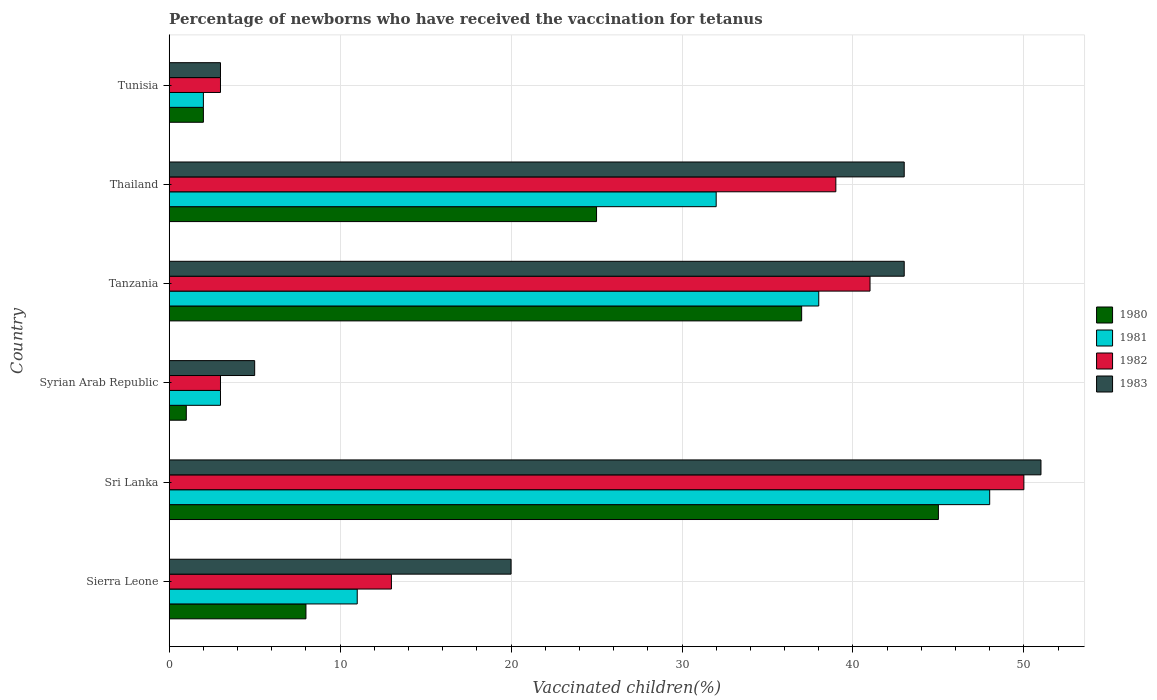How many groups of bars are there?
Provide a succinct answer. 6. Are the number of bars per tick equal to the number of legend labels?
Offer a terse response. Yes. How many bars are there on the 2nd tick from the bottom?
Your response must be concise. 4. What is the label of the 1st group of bars from the top?
Offer a terse response. Tunisia. What is the percentage of vaccinated children in 1983 in Tunisia?
Keep it short and to the point. 3. Across all countries, what is the minimum percentage of vaccinated children in 1981?
Ensure brevity in your answer.  2. In which country was the percentage of vaccinated children in 1980 maximum?
Make the answer very short. Sri Lanka. In which country was the percentage of vaccinated children in 1982 minimum?
Your answer should be very brief. Syrian Arab Republic. What is the total percentage of vaccinated children in 1983 in the graph?
Offer a terse response. 165. What is the difference between the percentage of vaccinated children in 1980 in Thailand and that in Tunisia?
Ensure brevity in your answer.  23. What is the difference between the percentage of vaccinated children in 1983 in Tunisia and the percentage of vaccinated children in 1980 in Tanzania?
Ensure brevity in your answer.  -34. What is the average percentage of vaccinated children in 1980 per country?
Provide a short and direct response. 19.67. What is the difference between the percentage of vaccinated children in 1981 and percentage of vaccinated children in 1983 in Sri Lanka?
Give a very brief answer. -3. In how many countries, is the percentage of vaccinated children in 1980 greater than 2 %?
Your answer should be very brief. 4. What is the ratio of the percentage of vaccinated children in 1983 in Tanzania to that in Thailand?
Give a very brief answer. 1. Is the percentage of vaccinated children in 1983 in Sierra Leone less than that in Syrian Arab Republic?
Your answer should be compact. No. Is the difference between the percentage of vaccinated children in 1981 in Sri Lanka and Thailand greater than the difference between the percentage of vaccinated children in 1983 in Sri Lanka and Thailand?
Keep it short and to the point. Yes. What is the difference between the highest and the second highest percentage of vaccinated children in 1982?
Your answer should be compact. 9. What is the difference between the highest and the lowest percentage of vaccinated children in 1980?
Offer a terse response. 44. In how many countries, is the percentage of vaccinated children in 1980 greater than the average percentage of vaccinated children in 1980 taken over all countries?
Your answer should be compact. 3. Is the sum of the percentage of vaccinated children in 1982 in Tanzania and Thailand greater than the maximum percentage of vaccinated children in 1980 across all countries?
Make the answer very short. Yes. What does the 2nd bar from the top in Syrian Arab Republic represents?
Offer a terse response. 1982. What does the 2nd bar from the bottom in Tunisia represents?
Offer a very short reply. 1981. Is it the case that in every country, the sum of the percentage of vaccinated children in 1983 and percentage of vaccinated children in 1981 is greater than the percentage of vaccinated children in 1982?
Give a very brief answer. Yes. Are all the bars in the graph horizontal?
Provide a succinct answer. Yes. Are the values on the major ticks of X-axis written in scientific E-notation?
Offer a terse response. No. Where does the legend appear in the graph?
Keep it short and to the point. Center right. How many legend labels are there?
Ensure brevity in your answer.  4. What is the title of the graph?
Make the answer very short. Percentage of newborns who have received the vaccination for tetanus. What is the label or title of the X-axis?
Offer a terse response. Vaccinated children(%). What is the Vaccinated children(%) of 1980 in Sierra Leone?
Ensure brevity in your answer.  8. What is the Vaccinated children(%) of 1982 in Sierra Leone?
Your response must be concise. 13. What is the Vaccinated children(%) in 1983 in Sierra Leone?
Provide a short and direct response. 20. What is the Vaccinated children(%) in 1980 in Sri Lanka?
Give a very brief answer. 45. What is the Vaccinated children(%) in 1981 in Sri Lanka?
Give a very brief answer. 48. What is the Vaccinated children(%) of 1980 in Syrian Arab Republic?
Give a very brief answer. 1. What is the Vaccinated children(%) in 1983 in Syrian Arab Republic?
Provide a short and direct response. 5. What is the Vaccinated children(%) in 1982 in Tanzania?
Provide a short and direct response. 41. What is the Vaccinated children(%) of 1980 in Thailand?
Provide a succinct answer. 25. What is the Vaccinated children(%) in 1982 in Thailand?
Your response must be concise. 39. What is the Vaccinated children(%) of 1980 in Tunisia?
Keep it short and to the point. 2. Across all countries, what is the maximum Vaccinated children(%) of 1980?
Your response must be concise. 45. Across all countries, what is the maximum Vaccinated children(%) in 1982?
Make the answer very short. 50. Across all countries, what is the maximum Vaccinated children(%) of 1983?
Give a very brief answer. 51. Across all countries, what is the minimum Vaccinated children(%) in 1981?
Your response must be concise. 2. Across all countries, what is the minimum Vaccinated children(%) in 1982?
Keep it short and to the point. 3. Across all countries, what is the minimum Vaccinated children(%) in 1983?
Offer a very short reply. 3. What is the total Vaccinated children(%) of 1980 in the graph?
Provide a succinct answer. 118. What is the total Vaccinated children(%) of 1981 in the graph?
Keep it short and to the point. 134. What is the total Vaccinated children(%) of 1982 in the graph?
Your answer should be compact. 149. What is the total Vaccinated children(%) in 1983 in the graph?
Your answer should be very brief. 165. What is the difference between the Vaccinated children(%) in 1980 in Sierra Leone and that in Sri Lanka?
Give a very brief answer. -37. What is the difference between the Vaccinated children(%) of 1981 in Sierra Leone and that in Sri Lanka?
Give a very brief answer. -37. What is the difference between the Vaccinated children(%) of 1982 in Sierra Leone and that in Sri Lanka?
Ensure brevity in your answer.  -37. What is the difference between the Vaccinated children(%) of 1983 in Sierra Leone and that in Sri Lanka?
Your answer should be compact. -31. What is the difference between the Vaccinated children(%) of 1982 in Sierra Leone and that in Syrian Arab Republic?
Your answer should be compact. 10. What is the difference between the Vaccinated children(%) in 1983 in Sierra Leone and that in Syrian Arab Republic?
Your answer should be compact. 15. What is the difference between the Vaccinated children(%) in 1980 in Sierra Leone and that in Tanzania?
Keep it short and to the point. -29. What is the difference between the Vaccinated children(%) in 1981 in Sierra Leone and that in Tanzania?
Your answer should be compact. -27. What is the difference between the Vaccinated children(%) in 1982 in Sierra Leone and that in Tanzania?
Ensure brevity in your answer.  -28. What is the difference between the Vaccinated children(%) in 1983 in Sierra Leone and that in Tanzania?
Provide a short and direct response. -23. What is the difference between the Vaccinated children(%) of 1980 in Sierra Leone and that in Thailand?
Give a very brief answer. -17. What is the difference between the Vaccinated children(%) in 1981 in Sierra Leone and that in Tunisia?
Your answer should be compact. 9. What is the difference between the Vaccinated children(%) of 1980 in Sri Lanka and that in Syrian Arab Republic?
Your answer should be compact. 44. What is the difference between the Vaccinated children(%) in 1981 in Sri Lanka and that in Syrian Arab Republic?
Give a very brief answer. 45. What is the difference between the Vaccinated children(%) of 1983 in Sri Lanka and that in Syrian Arab Republic?
Provide a short and direct response. 46. What is the difference between the Vaccinated children(%) in 1981 in Sri Lanka and that in Tanzania?
Your answer should be very brief. 10. What is the difference between the Vaccinated children(%) of 1982 in Sri Lanka and that in Tanzania?
Your answer should be compact. 9. What is the difference between the Vaccinated children(%) in 1980 in Sri Lanka and that in Thailand?
Ensure brevity in your answer.  20. What is the difference between the Vaccinated children(%) of 1983 in Sri Lanka and that in Thailand?
Your answer should be very brief. 8. What is the difference between the Vaccinated children(%) in 1982 in Sri Lanka and that in Tunisia?
Provide a short and direct response. 47. What is the difference between the Vaccinated children(%) of 1983 in Sri Lanka and that in Tunisia?
Provide a succinct answer. 48. What is the difference between the Vaccinated children(%) in 1980 in Syrian Arab Republic and that in Tanzania?
Ensure brevity in your answer.  -36. What is the difference between the Vaccinated children(%) of 1981 in Syrian Arab Republic and that in Tanzania?
Your answer should be compact. -35. What is the difference between the Vaccinated children(%) of 1982 in Syrian Arab Republic and that in Tanzania?
Provide a short and direct response. -38. What is the difference between the Vaccinated children(%) in 1983 in Syrian Arab Republic and that in Tanzania?
Offer a very short reply. -38. What is the difference between the Vaccinated children(%) in 1982 in Syrian Arab Republic and that in Thailand?
Make the answer very short. -36. What is the difference between the Vaccinated children(%) in 1983 in Syrian Arab Republic and that in Thailand?
Your answer should be compact. -38. What is the difference between the Vaccinated children(%) of 1981 in Syrian Arab Republic and that in Tunisia?
Your answer should be very brief. 1. What is the difference between the Vaccinated children(%) of 1982 in Syrian Arab Republic and that in Tunisia?
Your response must be concise. 0. What is the difference between the Vaccinated children(%) in 1982 in Tanzania and that in Thailand?
Make the answer very short. 2. What is the difference between the Vaccinated children(%) in 1983 in Tanzania and that in Thailand?
Provide a succinct answer. 0. What is the difference between the Vaccinated children(%) of 1981 in Tanzania and that in Tunisia?
Your answer should be compact. 36. What is the difference between the Vaccinated children(%) of 1983 in Tanzania and that in Tunisia?
Give a very brief answer. 40. What is the difference between the Vaccinated children(%) of 1980 in Thailand and that in Tunisia?
Give a very brief answer. 23. What is the difference between the Vaccinated children(%) of 1982 in Thailand and that in Tunisia?
Make the answer very short. 36. What is the difference between the Vaccinated children(%) of 1983 in Thailand and that in Tunisia?
Offer a very short reply. 40. What is the difference between the Vaccinated children(%) of 1980 in Sierra Leone and the Vaccinated children(%) of 1981 in Sri Lanka?
Provide a short and direct response. -40. What is the difference between the Vaccinated children(%) of 1980 in Sierra Leone and the Vaccinated children(%) of 1982 in Sri Lanka?
Give a very brief answer. -42. What is the difference between the Vaccinated children(%) of 1980 in Sierra Leone and the Vaccinated children(%) of 1983 in Sri Lanka?
Offer a terse response. -43. What is the difference between the Vaccinated children(%) in 1981 in Sierra Leone and the Vaccinated children(%) in 1982 in Sri Lanka?
Provide a short and direct response. -39. What is the difference between the Vaccinated children(%) of 1982 in Sierra Leone and the Vaccinated children(%) of 1983 in Sri Lanka?
Keep it short and to the point. -38. What is the difference between the Vaccinated children(%) of 1980 in Sierra Leone and the Vaccinated children(%) of 1981 in Syrian Arab Republic?
Offer a very short reply. 5. What is the difference between the Vaccinated children(%) of 1980 in Sierra Leone and the Vaccinated children(%) of 1982 in Syrian Arab Republic?
Your answer should be compact. 5. What is the difference between the Vaccinated children(%) of 1981 in Sierra Leone and the Vaccinated children(%) of 1982 in Syrian Arab Republic?
Provide a succinct answer. 8. What is the difference between the Vaccinated children(%) in 1981 in Sierra Leone and the Vaccinated children(%) in 1983 in Syrian Arab Republic?
Provide a short and direct response. 6. What is the difference between the Vaccinated children(%) in 1982 in Sierra Leone and the Vaccinated children(%) in 1983 in Syrian Arab Republic?
Your answer should be compact. 8. What is the difference between the Vaccinated children(%) of 1980 in Sierra Leone and the Vaccinated children(%) of 1982 in Tanzania?
Make the answer very short. -33. What is the difference between the Vaccinated children(%) in 1980 in Sierra Leone and the Vaccinated children(%) in 1983 in Tanzania?
Give a very brief answer. -35. What is the difference between the Vaccinated children(%) of 1981 in Sierra Leone and the Vaccinated children(%) of 1983 in Tanzania?
Offer a very short reply. -32. What is the difference between the Vaccinated children(%) of 1982 in Sierra Leone and the Vaccinated children(%) of 1983 in Tanzania?
Give a very brief answer. -30. What is the difference between the Vaccinated children(%) in 1980 in Sierra Leone and the Vaccinated children(%) in 1982 in Thailand?
Keep it short and to the point. -31. What is the difference between the Vaccinated children(%) of 1980 in Sierra Leone and the Vaccinated children(%) of 1983 in Thailand?
Make the answer very short. -35. What is the difference between the Vaccinated children(%) in 1981 in Sierra Leone and the Vaccinated children(%) in 1983 in Thailand?
Give a very brief answer. -32. What is the difference between the Vaccinated children(%) in 1982 in Sierra Leone and the Vaccinated children(%) in 1983 in Thailand?
Your response must be concise. -30. What is the difference between the Vaccinated children(%) in 1980 in Sierra Leone and the Vaccinated children(%) in 1981 in Tunisia?
Keep it short and to the point. 6. What is the difference between the Vaccinated children(%) in 1980 in Sierra Leone and the Vaccinated children(%) in 1982 in Tunisia?
Offer a terse response. 5. What is the difference between the Vaccinated children(%) in 1980 in Sierra Leone and the Vaccinated children(%) in 1983 in Tunisia?
Make the answer very short. 5. What is the difference between the Vaccinated children(%) of 1981 in Sierra Leone and the Vaccinated children(%) of 1982 in Tunisia?
Your response must be concise. 8. What is the difference between the Vaccinated children(%) in 1981 in Sierra Leone and the Vaccinated children(%) in 1983 in Tunisia?
Offer a terse response. 8. What is the difference between the Vaccinated children(%) of 1982 in Sierra Leone and the Vaccinated children(%) of 1983 in Tunisia?
Provide a succinct answer. 10. What is the difference between the Vaccinated children(%) of 1980 in Sri Lanka and the Vaccinated children(%) of 1982 in Syrian Arab Republic?
Offer a terse response. 42. What is the difference between the Vaccinated children(%) in 1980 in Sri Lanka and the Vaccinated children(%) in 1983 in Syrian Arab Republic?
Provide a short and direct response. 40. What is the difference between the Vaccinated children(%) in 1981 in Sri Lanka and the Vaccinated children(%) in 1982 in Syrian Arab Republic?
Keep it short and to the point. 45. What is the difference between the Vaccinated children(%) in 1981 in Sri Lanka and the Vaccinated children(%) in 1983 in Syrian Arab Republic?
Your answer should be very brief. 43. What is the difference between the Vaccinated children(%) in 1982 in Sri Lanka and the Vaccinated children(%) in 1983 in Syrian Arab Republic?
Keep it short and to the point. 45. What is the difference between the Vaccinated children(%) of 1980 in Sri Lanka and the Vaccinated children(%) of 1982 in Tanzania?
Your answer should be compact. 4. What is the difference between the Vaccinated children(%) in 1981 in Sri Lanka and the Vaccinated children(%) in 1982 in Tanzania?
Make the answer very short. 7. What is the difference between the Vaccinated children(%) in 1981 in Sri Lanka and the Vaccinated children(%) in 1983 in Tanzania?
Your response must be concise. 5. What is the difference between the Vaccinated children(%) of 1980 in Sri Lanka and the Vaccinated children(%) of 1983 in Thailand?
Offer a terse response. 2. What is the difference between the Vaccinated children(%) in 1981 in Sri Lanka and the Vaccinated children(%) in 1982 in Thailand?
Provide a short and direct response. 9. What is the difference between the Vaccinated children(%) of 1981 in Sri Lanka and the Vaccinated children(%) of 1983 in Thailand?
Give a very brief answer. 5. What is the difference between the Vaccinated children(%) of 1980 in Sri Lanka and the Vaccinated children(%) of 1981 in Tunisia?
Your answer should be very brief. 43. What is the difference between the Vaccinated children(%) of 1980 in Sri Lanka and the Vaccinated children(%) of 1983 in Tunisia?
Provide a succinct answer. 42. What is the difference between the Vaccinated children(%) in 1981 in Sri Lanka and the Vaccinated children(%) in 1982 in Tunisia?
Provide a succinct answer. 45. What is the difference between the Vaccinated children(%) of 1980 in Syrian Arab Republic and the Vaccinated children(%) of 1981 in Tanzania?
Provide a short and direct response. -37. What is the difference between the Vaccinated children(%) in 1980 in Syrian Arab Republic and the Vaccinated children(%) in 1982 in Tanzania?
Your response must be concise. -40. What is the difference between the Vaccinated children(%) in 1980 in Syrian Arab Republic and the Vaccinated children(%) in 1983 in Tanzania?
Make the answer very short. -42. What is the difference between the Vaccinated children(%) in 1981 in Syrian Arab Republic and the Vaccinated children(%) in 1982 in Tanzania?
Your response must be concise. -38. What is the difference between the Vaccinated children(%) in 1980 in Syrian Arab Republic and the Vaccinated children(%) in 1981 in Thailand?
Provide a succinct answer. -31. What is the difference between the Vaccinated children(%) of 1980 in Syrian Arab Republic and the Vaccinated children(%) of 1982 in Thailand?
Your response must be concise. -38. What is the difference between the Vaccinated children(%) in 1980 in Syrian Arab Republic and the Vaccinated children(%) in 1983 in Thailand?
Offer a terse response. -42. What is the difference between the Vaccinated children(%) in 1981 in Syrian Arab Republic and the Vaccinated children(%) in 1982 in Thailand?
Your response must be concise. -36. What is the difference between the Vaccinated children(%) in 1982 in Syrian Arab Republic and the Vaccinated children(%) in 1983 in Thailand?
Your answer should be compact. -40. What is the difference between the Vaccinated children(%) in 1980 in Syrian Arab Republic and the Vaccinated children(%) in 1982 in Tunisia?
Give a very brief answer. -2. What is the difference between the Vaccinated children(%) of 1981 in Syrian Arab Republic and the Vaccinated children(%) of 1983 in Tunisia?
Keep it short and to the point. 0. What is the difference between the Vaccinated children(%) in 1982 in Tanzania and the Vaccinated children(%) in 1983 in Thailand?
Give a very brief answer. -2. What is the difference between the Vaccinated children(%) of 1980 in Tanzania and the Vaccinated children(%) of 1983 in Tunisia?
Provide a short and direct response. 34. What is the difference between the Vaccinated children(%) of 1980 in Thailand and the Vaccinated children(%) of 1981 in Tunisia?
Provide a short and direct response. 23. What is the difference between the Vaccinated children(%) in 1980 in Thailand and the Vaccinated children(%) in 1982 in Tunisia?
Offer a terse response. 22. What is the difference between the Vaccinated children(%) of 1980 in Thailand and the Vaccinated children(%) of 1983 in Tunisia?
Your response must be concise. 22. What is the difference between the Vaccinated children(%) of 1981 in Thailand and the Vaccinated children(%) of 1982 in Tunisia?
Provide a short and direct response. 29. What is the difference between the Vaccinated children(%) of 1982 in Thailand and the Vaccinated children(%) of 1983 in Tunisia?
Offer a terse response. 36. What is the average Vaccinated children(%) in 1980 per country?
Offer a very short reply. 19.67. What is the average Vaccinated children(%) in 1981 per country?
Make the answer very short. 22.33. What is the average Vaccinated children(%) in 1982 per country?
Offer a terse response. 24.83. What is the average Vaccinated children(%) in 1983 per country?
Keep it short and to the point. 27.5. What is the difference between the Vaccinated children(%) in 1980 and Vaccinated children(%) in 1983 in Sierra Leone?
Make the answer very short. -12. What is the difference between the Vaccinated children(%) in 1981 and Vaccinated children(%) in 1982 in Sierra Leone?
Provide a short and direct response. -2. What is the difference between the Vaccinated children(%) of 1980 and Vaccinated children(%) of 1982 in Sri Lanka?
Keep it short and to the point. -5. What is the difference between the Vaccinated children(%) of 1981 and Vaccinated children(%) of 1982 in Sri Lanka?
Your answer should be compact. -2. What is the difference between the Vaccinated children(%) in 1981 and Vaccinated children(%) in 1983 in Sri Lanka?
Ensure brevity in your answer.  -3. What is the difference between the Vaccinated children(%) of 1982 and Vaccinated children(%) of 1983 in Sri Lanka?
Your response must be concise. -1. What is the difference between the Vaccinated children(%) in 1980 and Vaccinated children(%) in 1981 in Syrian Arab Republic?
Keep it short and to the point. -2. What is the difference between the Vaccinated children(%) of 1980 and Vaccinated children(%) of 1983 in Syrian Arab Republic?
Provide a short and direct response. -4. What is the difference between the Vaccinated children(%) of 1981 and Vaccinated children(%) of 1983 in Syrian Arab Republic?
Offer a very short reply. -2. What is the difference between the Vaccinated children(%) in 1982 and Vaccinated children(%) in 1983 in Syrian Arab Republic?
Offer a terse response. -2. What is the difference between the Vaccinated children(%) in 1980 and Vaccinated children(%) in 1981 in Tanzania?
Your answer should be very brief. -1. What is the difference between the Vaccinated children(%) of 1980 and Vaccinated children(%) of 1982 in Tanzania?
Your response must be concise. -4. What is the difference between the Vaccinated children(%) in 1980 and Vaccinated children(%) in 1983 in Tanzania?
Your answer should be compact. -6. What is the difference between the Vaccinated children(%) in 1982 and Vaccinated children(%) in 1983 in Tanzania?
Ensure brevity in your answer.  -2. What is the difference between the Vaccinated children(%) of 1980 and Vaccinated children(%) of 1981 in Thailand?
Give a very brief answer. -7. What is the difference between the Vaccinated children(%) in 1980 and Vaccinated children(%) in 1982 in Thailand?
Keep it short and to the point. -14. What is the difference between the Vaccinated children(%) of 1981 and Vaccinated children(%) of 1982 in Thailand?
Provide a short and direct response. -7. What is the difference between the Vaccinated children(%) in 1981 and Vaccinated children(%) in 1983 in Thailand?
Make the answer very short. -11. What is the difference between the Vaccinated children(%) of 1980 and Vaccinated children(%) of 1981 in Tunisia?
Offer a terse response. 0. What is the difference between the Vaccinated children(%) of 1980 and Vaccinated children(%) of 1982 in Tunisia?
Keep it short and to the point. -1. What is the difference between the Vaccinated children(%) in 1981 and Vaccinated children(%) in 1983 in Tunisia?
Your answer should be compact. -1. What is the ratio of the Vaccinated children(%) of 1980 in Sierra Leone to that in Sri Lanka?
Offer a very short reply. 0.18. What is the ratio of the Vaccinated children(%) in 1981 in Sierra Leone to that in Sri Lanka?
Provide a short and direct response. 0.23. What is the ratio of the Vaccinated children(%) of 1982 in Sierra Leone to that in Sri Lanka?
Your answer should be very brief. 0.26. What is the ratio of the Vaccinated children(%) in 1983 in Sierra Leone to that in Sri Lanka?
Give a very brief answer. 0.39. What is the ratio of the Vaccinated children(%) in 1981 in Sierra Leone to that in Syrian Arab Republic?
Provide a succinct answer. 3.67. What is the ratio of the Vaccinated children(%) in 1982 in Sierra Leone to that in Syrian Arab Republic?
Provide a succinct answer. 4.33. What is the ratio of the Vaccinated children(%) in 1983 in Sierra Leone to that in Syrian Arab Republic?
Your answer should be very brief. 4. What is the ratio of the Vaccinated children(%) in 1980 in Sierra Leone to that in Tanzania?
Ensure brevity in your answer.  0.22. What is the ratio of the Vaccinated children(%) in 1981 in Sierra Leone to that in Tanzania?
Your response must be concise. 0.29. What is the ratio of the Vaccinated children(%) of 1982 in Sierra Leone to that in Tanzania?
Provide a succinct answer. 0.32. What is the ratio of the Vaccinated children(%) in 1983 in Sierra Leone to that in Tanzania?
Offer a terse response. 0.47. What is the ratio of the Vaccinated children(%) of 1980 in Sierra Leone to that in Thailand?
Give a very brief answer. 0.32. What is the ratio of the Vaccinated children(%) in 1981 in Sierra Leone to that in Thailand?
Give a very brief answer. 0.34. What is the ratio of the Vaccinated children(%) in 1983 in Sierra Leone to that in Thailand?
Your answer should be very brief. 0.47. What is the ratio of the Vaccinated children(%) in 1980 in Sierra Leone to that in Tunisia?
Give a very brief answer. 4. What is the ratio of the Vaccinated children(%) of 1982 in Sierra Leone to that in Tunisia?
Offer a terse response. 4.33. What is the ratio of the Vaccinated children(%) in 1980 in Sri Lanka to that in Syrian Arab Republic?
Provide a short and direct response. 45. What is the ratio of the Vaccinated children(%) of 1981 in Sri Lanka to that in Syrian Arab Republic?
Give a very brief answer. 16. What is the ratio of the Vaccinated children(%) in 1982 in Sri Lanka to that in Syrian Arab Republic?
Keep it short and to the point. 16.67. What is the ratio of the Vaccinated children(%) in 1980 in Sri Lanka to that in Tanzania?
Provide a succinct answer. 1.22. What is the ratio of the Vaccinated children(%) of 1981 in Sri Lanka to that in Tanzania?
Ensure brevity in your answer.  1.26. What is the ratio of the Vaccinated children(%) of 1982 in Sri Lanka to that in Tanzania?
Ensure brevity in your answer.  1.22. What is the ratio of the Vaccinated children(%) in 1983 in Sri Lanka to that in Tanzania?
Offer a very short reply. 1.19. What is the ratio of the Vaccinated children(%) in 1982 in Sri Lanka to that in Thailand?
Your answer should be very brief. 1.28. What is the ratio of the Vaccinated children(%) of 1983 in Sri Lanka to that in Thailand?
Provide a short and direct response. 1.19. What is the ratio of the Vaccinated children(%) of 1980 in Sri Lanka to that in Tunisia?
Ensure brevity in your answer.  22.5. What is the ratio of the Vaccinated children(%) of 1981 in Sri Lanka to that in Tunisia?
Your answer should be compact. 24. What is the ratio of the Vaccinated children(%) of 1982 in Sri Lanka to that in Tunisia?
Your response must be concise. 16.67. What is the ratio of the Vaccinated children(%) of 1980 in Syrian Arab Republic to that in Tanzania?
Make the answer very short. 0.03. What is the ratio of the Vaccinated children(%) of 1981 in Syrian Arab Republic to that in Tanzania?
Your answer should be compact. 0.08. What is the ratio of the Vaccinated children(%) in 1982 in Syrian Arab Republic to that in Tanzania?
Provide a succinct answer. 0.07. What is the ratio of the Vaccinated children(%) of 1983 in Syrian Arab Republic to that in Tanzania?
Make the answer very short. 0.12. What is the ratio of the Vaccinated children(%) of 1981 in Syrian Arab Republic to that in Thailand?
Ensure brevity in your answer.  0.09. What is the ratio of the Vaccinated children(%) in 1982 in Syrian Arab Republic to that in Thailand?
Provide a short and direct response. 0.08. What is the ratio of the Vaccinated children(%) in 1983 in Syrian Arab Republic to that in Thailand?
Your response must be concise. 0.12. What is the ratio of the Vaccinated children(%) of 1980 in Syrian Arab Republic to that in Tunisia?
Keep it short and to the point. 0.5. What is the ratio of the Vaccinated children(%) in 1981 in Syrian Arab Republic to that in Tunisia?
Provide a succinct answer. 1.5. What is the ratio of the Vaccinated children(%) of 1980 in Tanzania to that in Thailand?
Your answer should be very brief. 1.48. What is the ratio of the Vaccinated children(%) of 1981 in Tanzania to that in Thailand?
Provide a short and direct response. 1.19. What is the ratio of the Vaccinated children(%) of 1982 in Tanzania to that in Thailand?
Your answer should be very brief. 1.05. What is the ratio of the Vaccinated children(%) in 1983 in Tanzania to that in Thailand?
Offer a terse response. 1. What is the ratio of the Vaccinated children(%) of 1981 in Tanzania to that in Tunisia?
Give a very brief answer. 19. What is the ratio of the Vaccinated children(%) of 1982 in Tanzania to that in Tunisia?
Give a very brief answer. 13.67. What is the ratio of the Vaccinated children(%) of 1983 in Tanzania to that in Tunisia?
Your answer should be very brief. 14.33. What is the ratio of the Vaccinated children(%) in 1982 in Thailand to that in Tunisia?
Offer a terse response. 13. What is the ratio of the Vaccinated children(%) in 1983 in Thailand to that in Tunisia?
Your answer should be compact. 14.33. What is the difference between the highest and the second highest Vaccinated children(%) of 1980?
Offer a terse response. 8. What is the difference between the highest and the lowest Vaccinated children(%) in 1980?
Give a very brief answer. 44. What is the difference between the highest and the lowest Vaccinated children(%) in 1981?
Provide a succinct answer. 46. What is the difference between the highest and the lowest Vaccinated children(%) in 1982?
Offer a very short reply. 47. What is the difference between the highest and the lowest Vaccinated children(%) in 1983?
Provide a succinct answer. 48. 